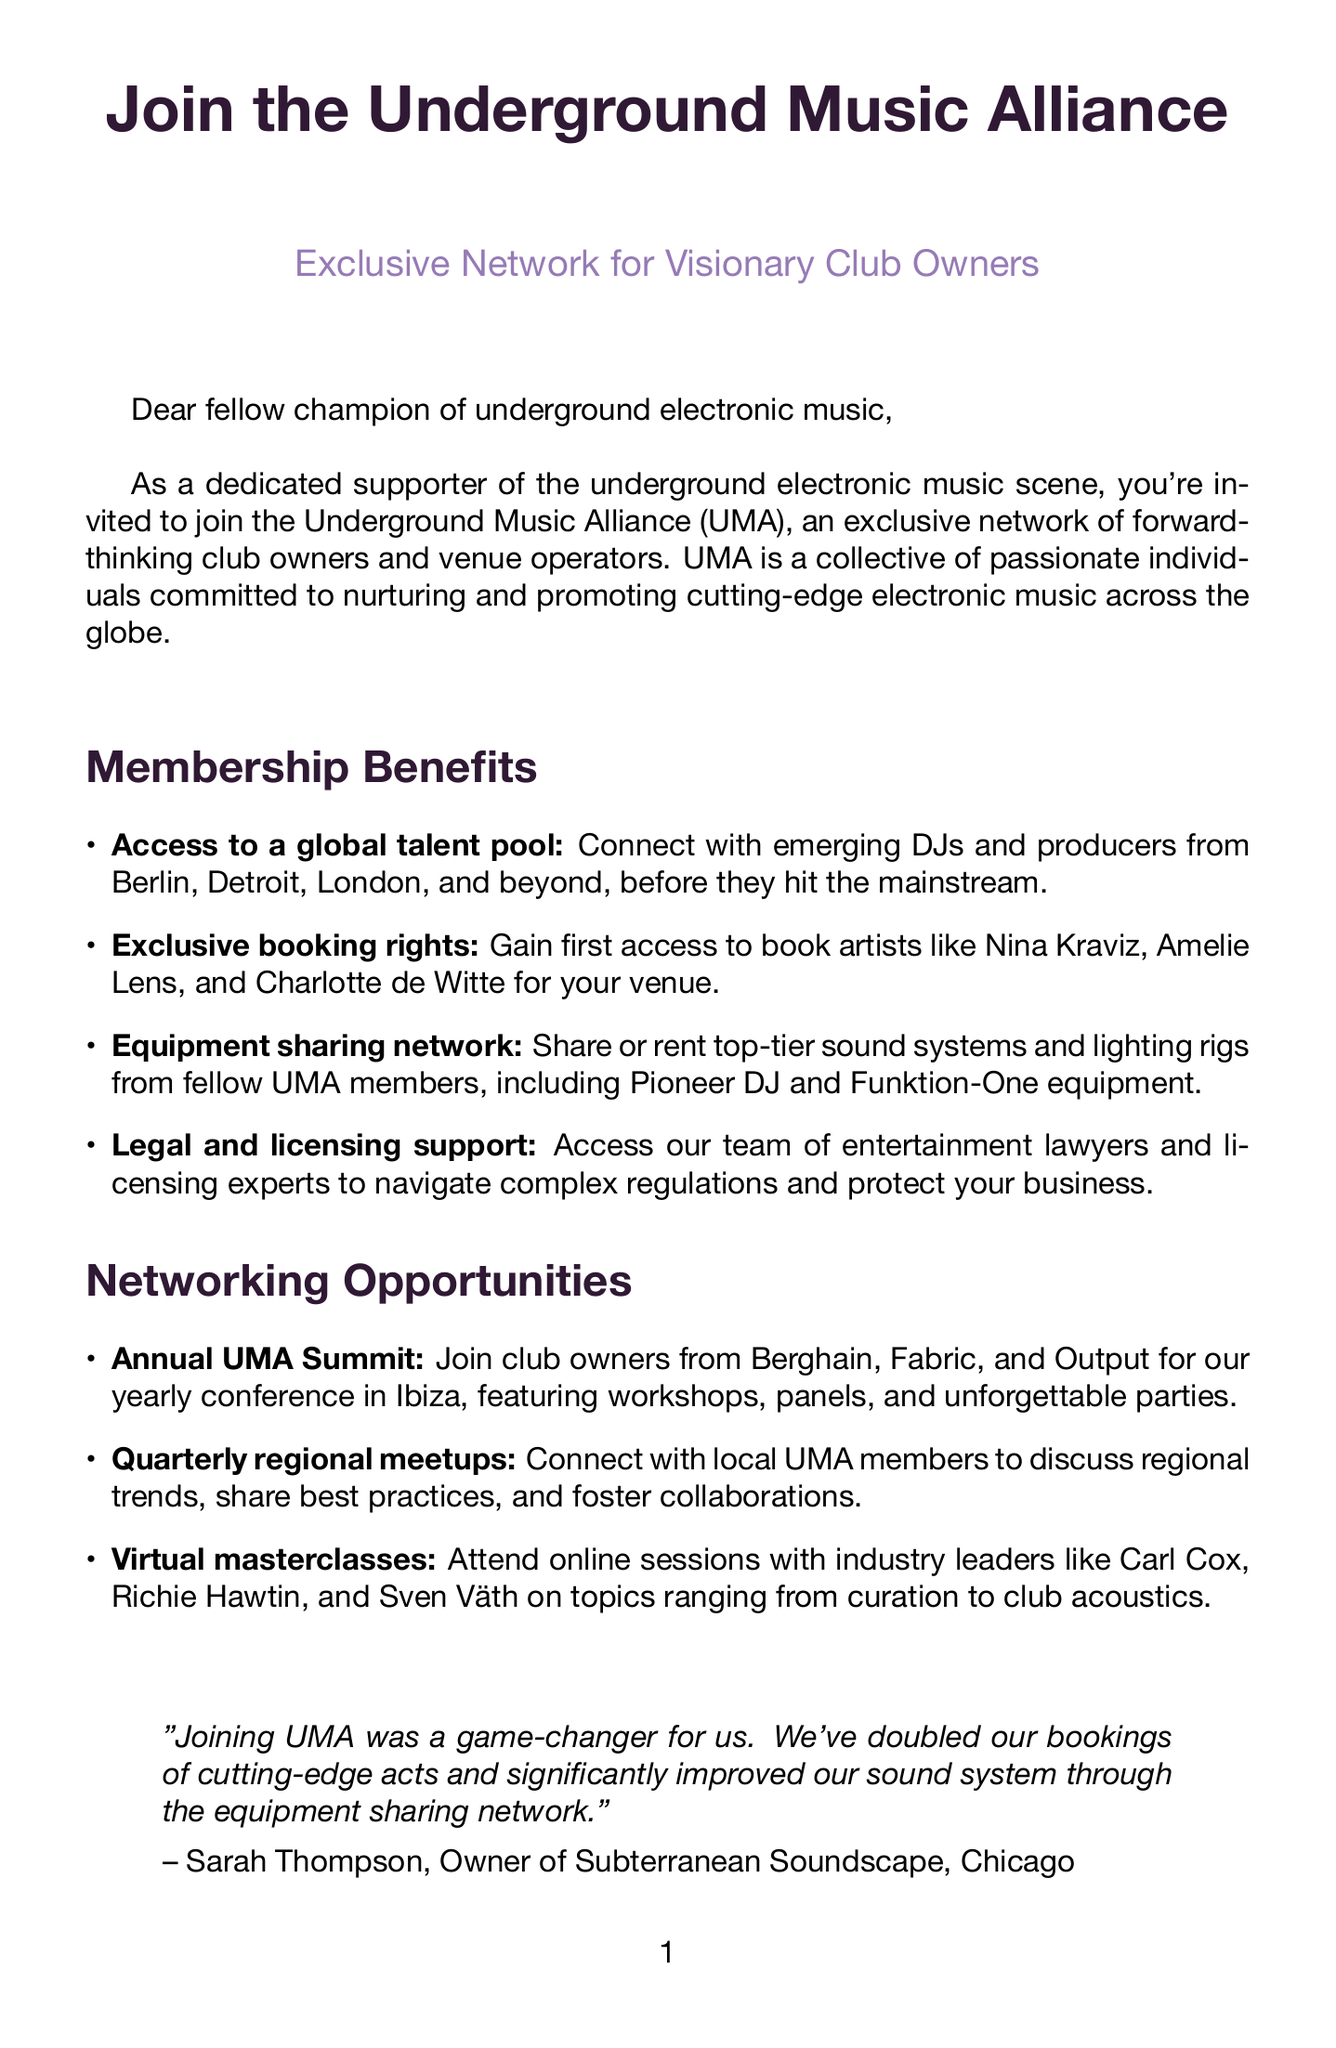What is the name of the alliance? The name of the alliance is mentioned in the title of the letter.
Answer: Underground Music Alliance Who is the founder of UMA? The founder of UMA is mentioned at the end of the letter.
Answer: Alex Moreno What are the exclusive booking rights? The benefit describes gaining first access to book well-known electronic music artists.
Answer: Artists like Nina Kraviz, Amelie Lens, and Charlotte de Witte Where is the Annual UMA Summit held? The location of the Annual UMA Summit is specified in the document.
Answer: Ibiza What is one of the benefits of the equipment sharing network? The description of the equipment sharing network specifies types of equipment available.
Answer: Pioneer DJ and Funktion-One equipment How often are the regional meetups held? The document specifies the frequency of these events.
Answer: Quarterly What did Sarah Thompson say about joining UMA? The testimonial includes Sarah Thompson's perspective on joining the alliance.
Answer: A game-changer for us What is the primary focus of the Underground Music Alliance? The main point in the introduction summarizes the focus of the alliance.
Answer: Cutting-edge electronic music What do virtual masterclasses feature? The description highlights who leads these online sessions and their topics.
Answer: Industry leaders like Carl Cox, Richie Hawtin, and Sven Väth 